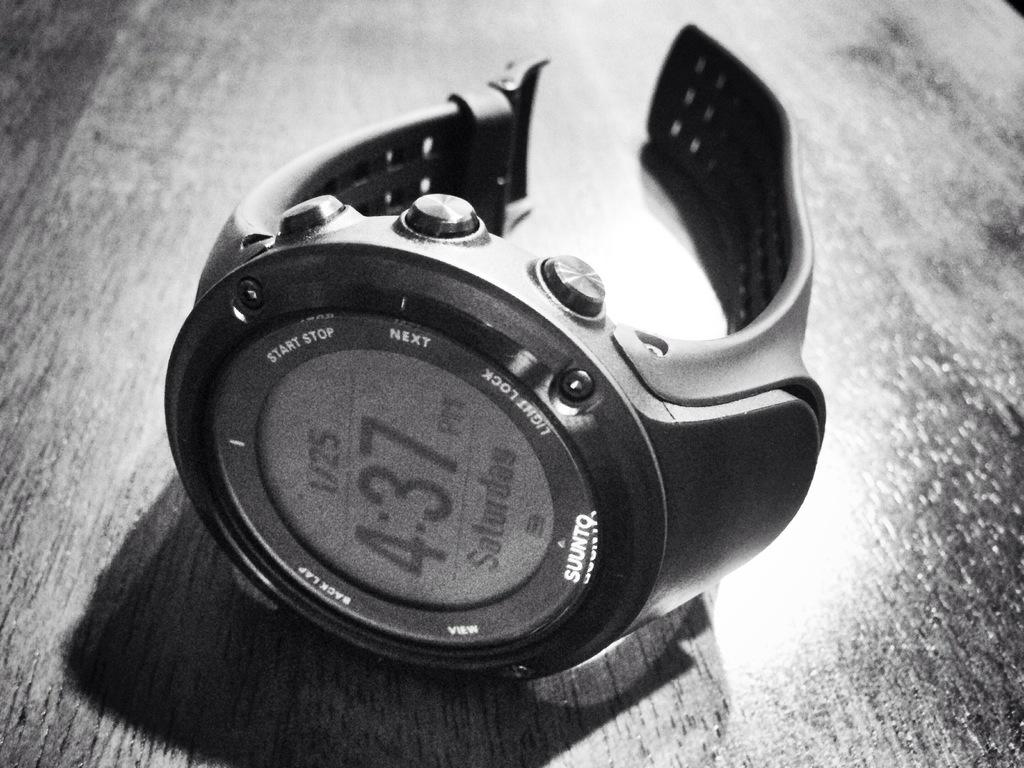Provide a one-sentence caption for the provided image. A Suunto brand watch lies on its side on a wooden table. 